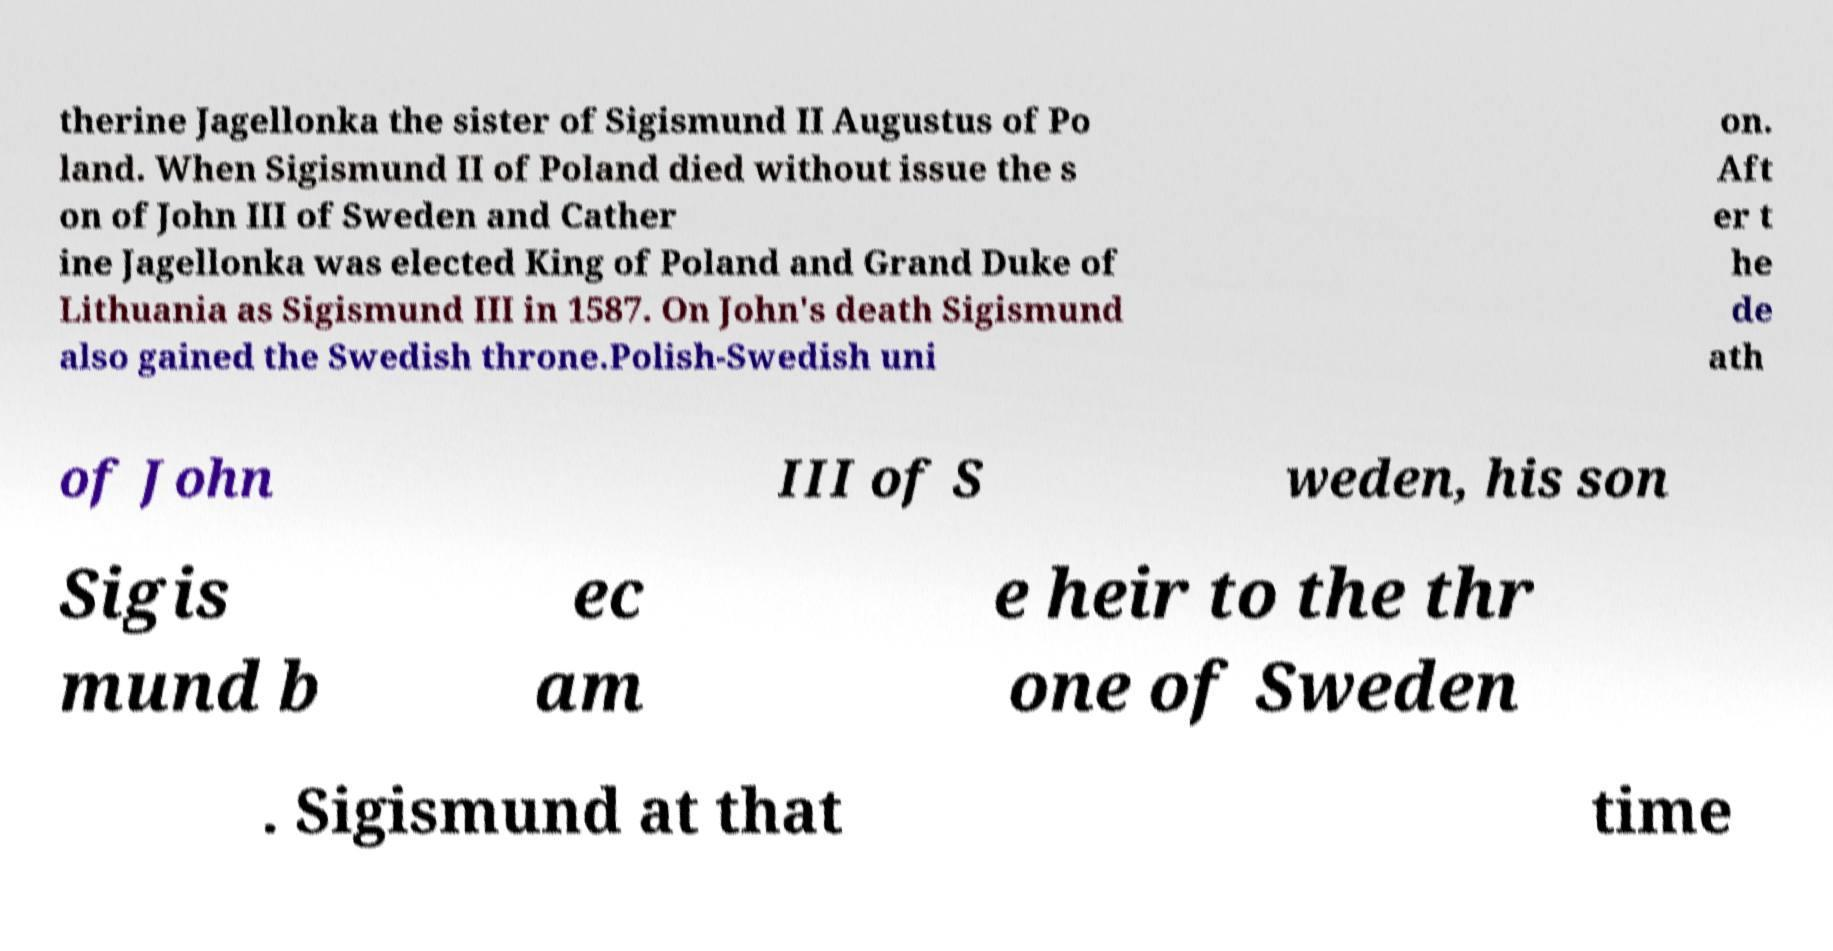Can you read and provide the text displayed in the image?This photo seems to have some interesting text. Can you extract and type it out for me? therine Jagellonka the sister of Sigismund II Augustus of Po land. When Sigismund II of Poland died without issue the s on of John III of Sweden and Cather ine Jagellonka was elected King of Poland and Grand Duke of Lithuania as Sigismund III in 1587. On John's death Sigismund also gained the Swedish throne.Polish-Swedish uni on. Aft er t he de ath of John III of S weden, his son Sigis mund b ec am e heir to the thr one of Sweden . Sigismund at that time 